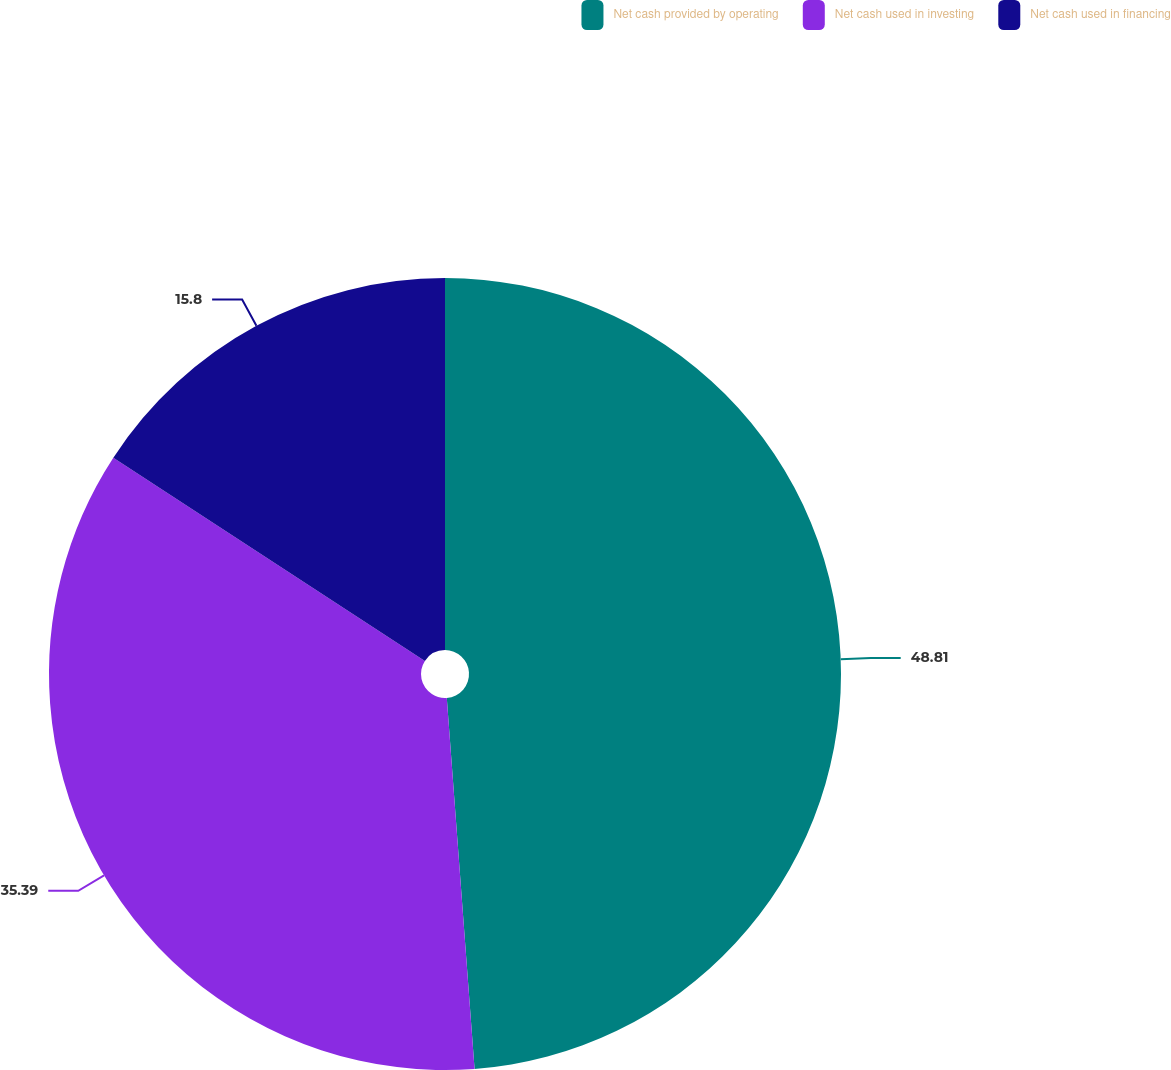Convert chart to OTSL. <chart><loc_0><loc_0><loc_500><loc_500><pie_chart><fcel>Net cash provided by operating<fcel>Net cash used in investing<fcel>Net cash used in financing<nl><fcel>48.81%<fcel>35.39%<fcel>15.8%<nl></chart> 